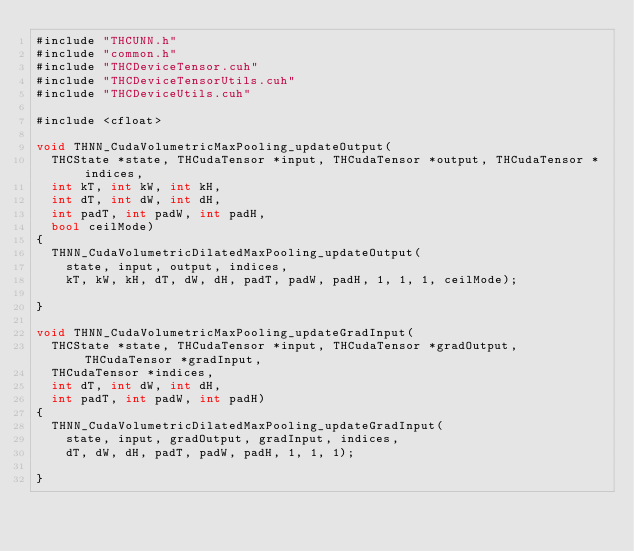Convert code to text. <code><loc_0><loc_0><loc_500><loc_500><_Cuda_>#include "THCUNN.h"
#include "common.h"
#include "THCDeviceTensor.cuh"
#include "THCDeviceTensorUtils.cuh"
#include "THCDeviceUtils.cuh"

#include <cfloat>

void THNN_CudaVolumetricMaxPooling_updateOutput(
  THCState *state, THCudaTensor *input, THCudaTensor *output, THCudaTensor *indices,
  int kT, int kW, int kH,
  int dT, int dW, int dH,
  int padT, int padW, int padH,
  bool ceilMode)
{
  THNN_CudaVolumetricDilatedMaxPooling_updateOutput(
    state, input, output, indices,
    kT, kW, kH, dT, dW, dH, padT, padW, padH, 1, 1, 1, ceilMode);

}

void THNN_CudaVolumetricMaxPooling_updateGradInput(
  THCState *state, THCudaTensor *input, THCudaTensor *gradOutput, THCudaTensor *gradInput,
  THCudaTensor *indices,
  int dT, int dW, int dH,
  int padT, int padW, int padH)
{
  THNN_CudaVolumetricDilatedMaxPooling_updateGradInput(
    state, input, gradOutput, gradInput, indices,
    dT, dW, dH, padT, padW, padH, 1, 1, 1);

}
</code> 